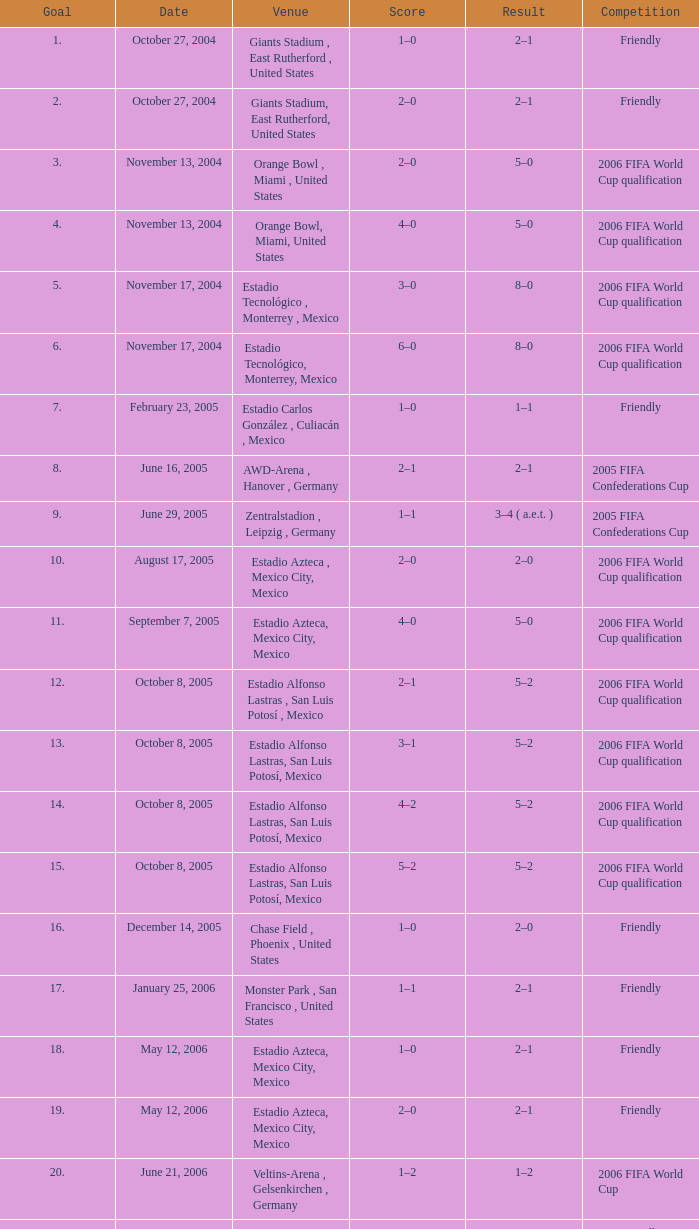Which outcome has a score of 1-0, and a goal of 16? 2–0. 